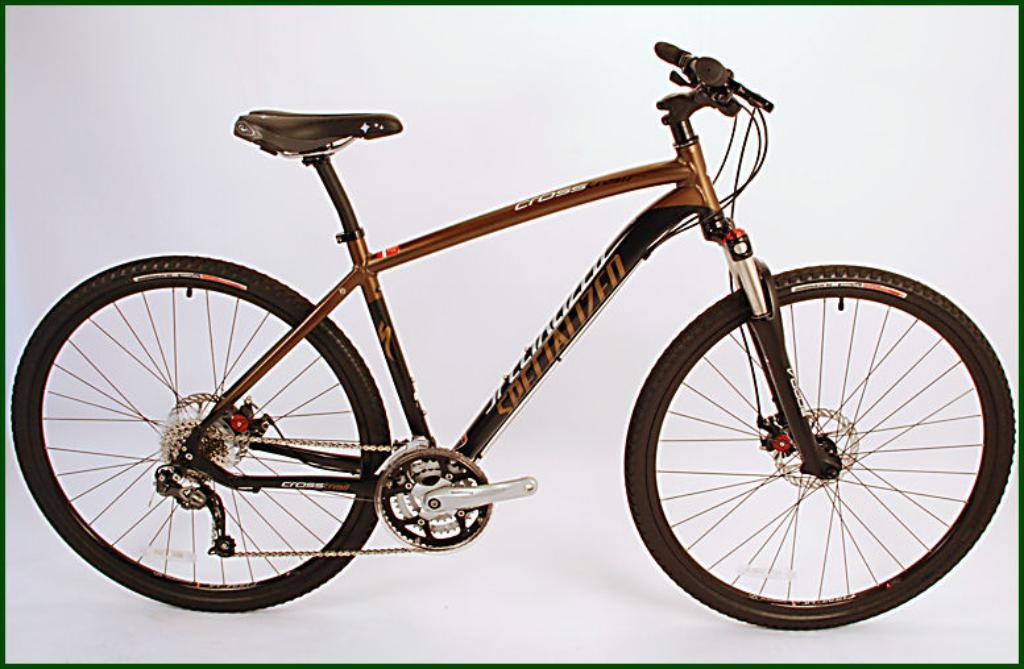What is the main object in the image? There is a bicycle in the image. What is the color of the surface the bicycle is on? The bicycle is on a white surface. What type of vessel is being used to transport the bicycle in the image? There is no vessel present in the image; the bicycle is on a white surface. How is the lace incorporated into the design of the bicycle in the image? There is no lace present in the image; the bicycle is on a white surface. 